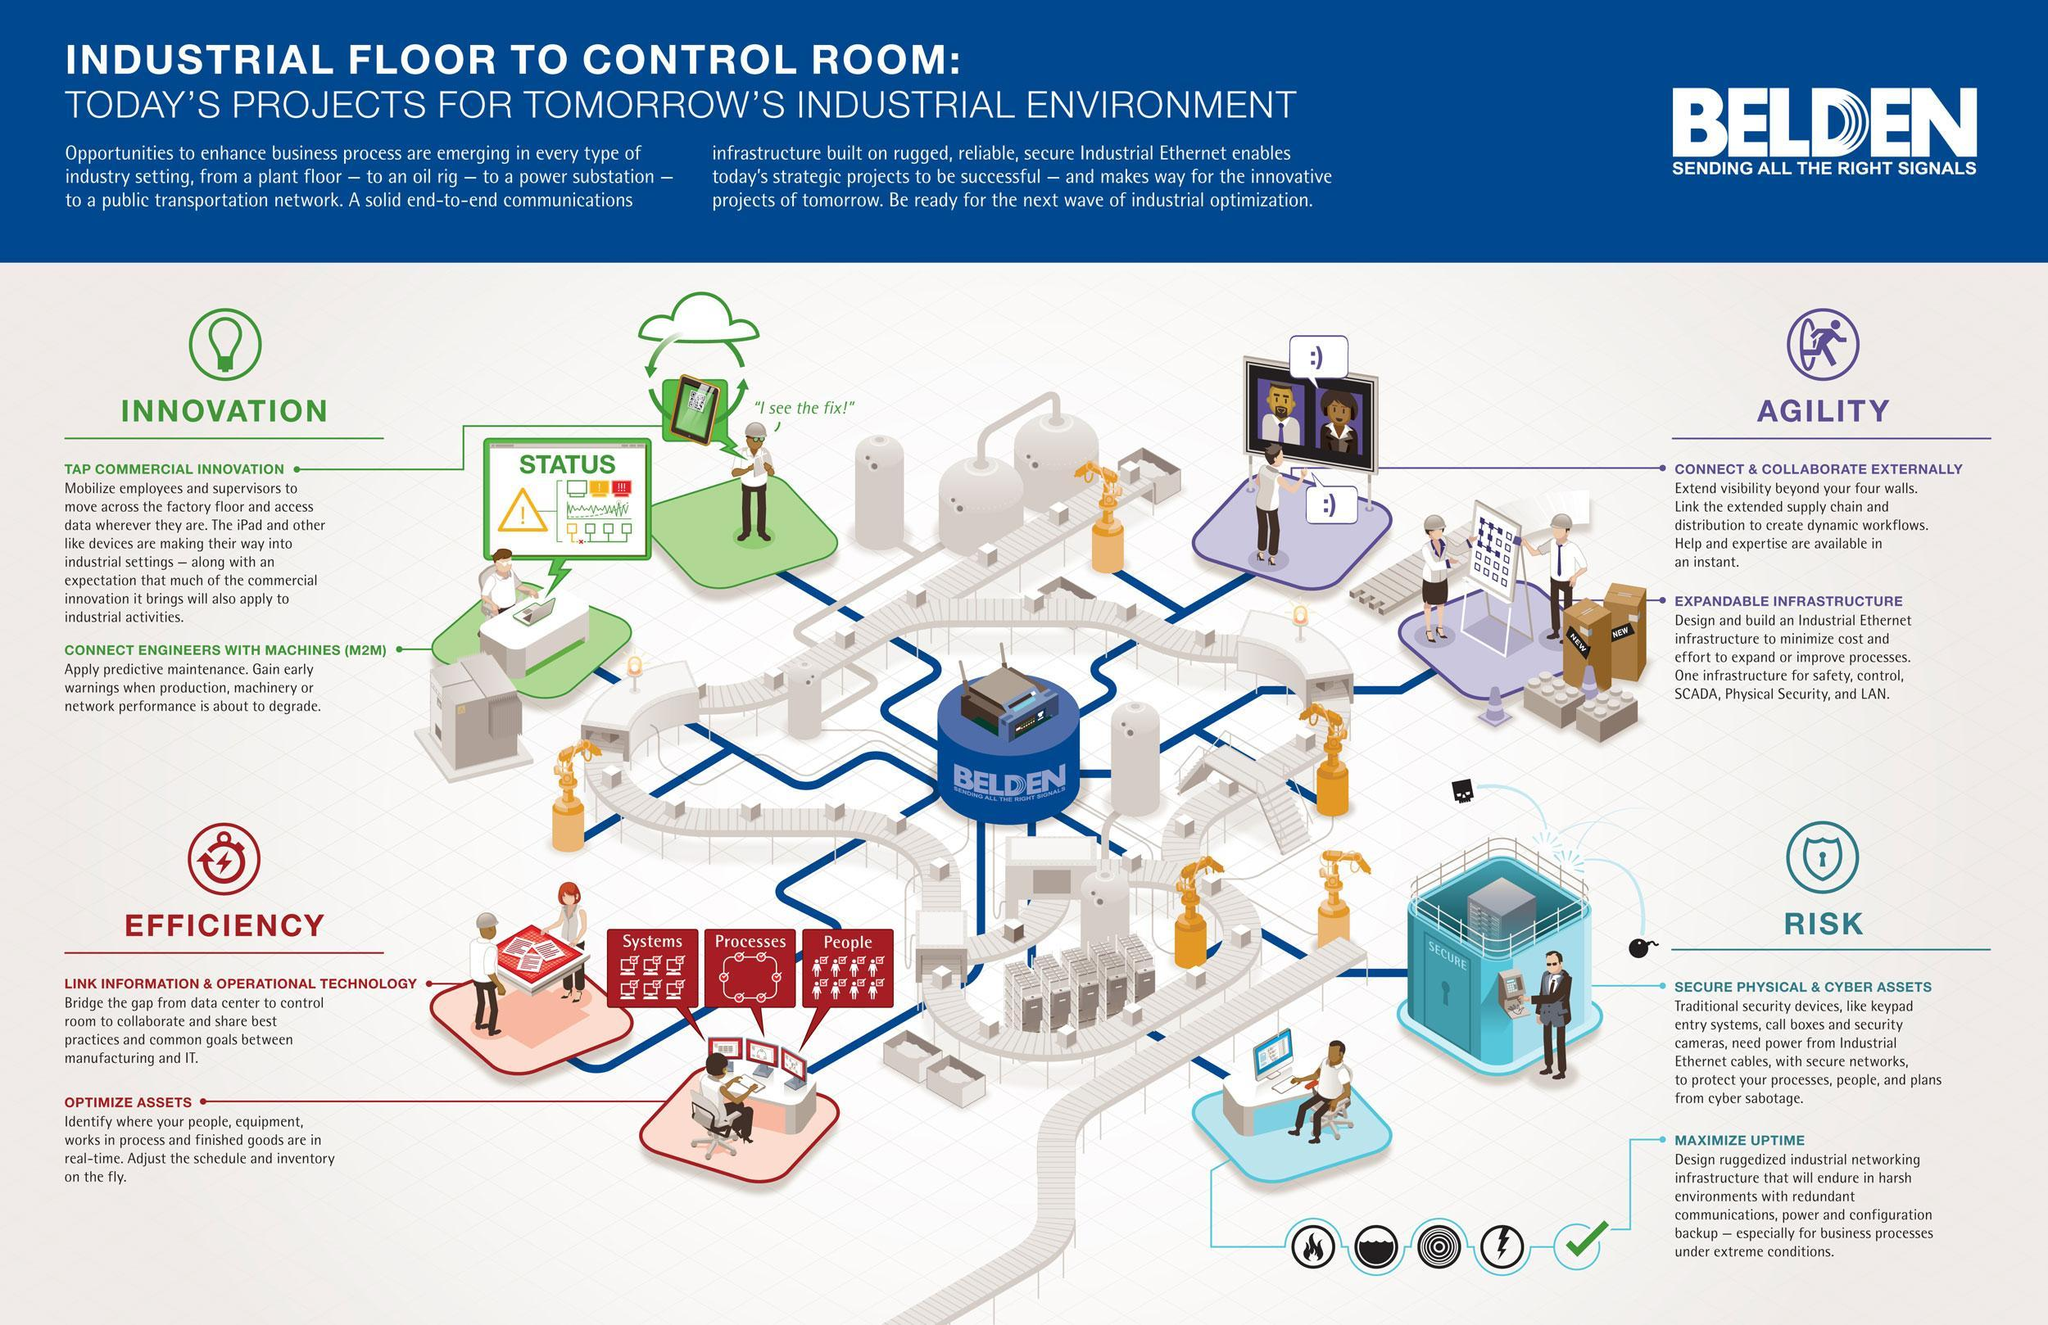what are the 3 factors for asset optimization
Answer the question with a short phrase. Systems, Processes, People What factors to be considered in efficiency Link Information & Operational Technology, Optimize Assets what are the risks that need to be managed Secure Physical & Cyber Assets, Maximize Uptime What are the 2 key factors in innovation tap commercial innovation, connect engineers with machines (M2M) WHat are the key factors for Agility Connect & collaborate externally, expandable infrastructure 